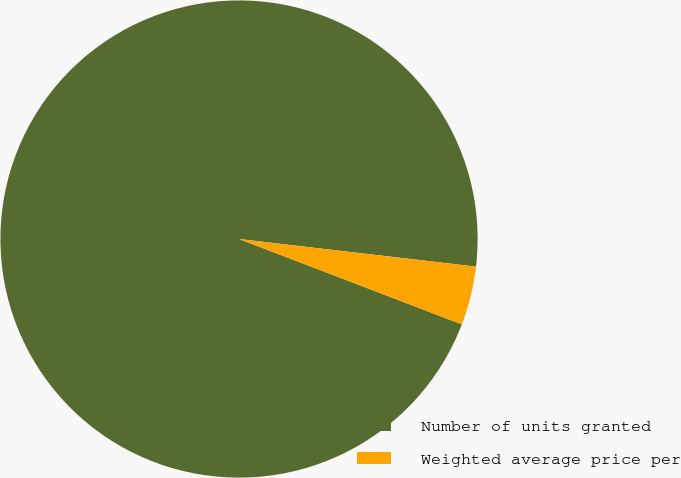Convert chart to OTSL. <chart><loc_0><loc_0><loc_500><loc_500><pie_chart><fcel>Number of units granted<fcel>Weighted average price per<nl><fcel>96.02%<fcel>3.98%<nl></chart> 